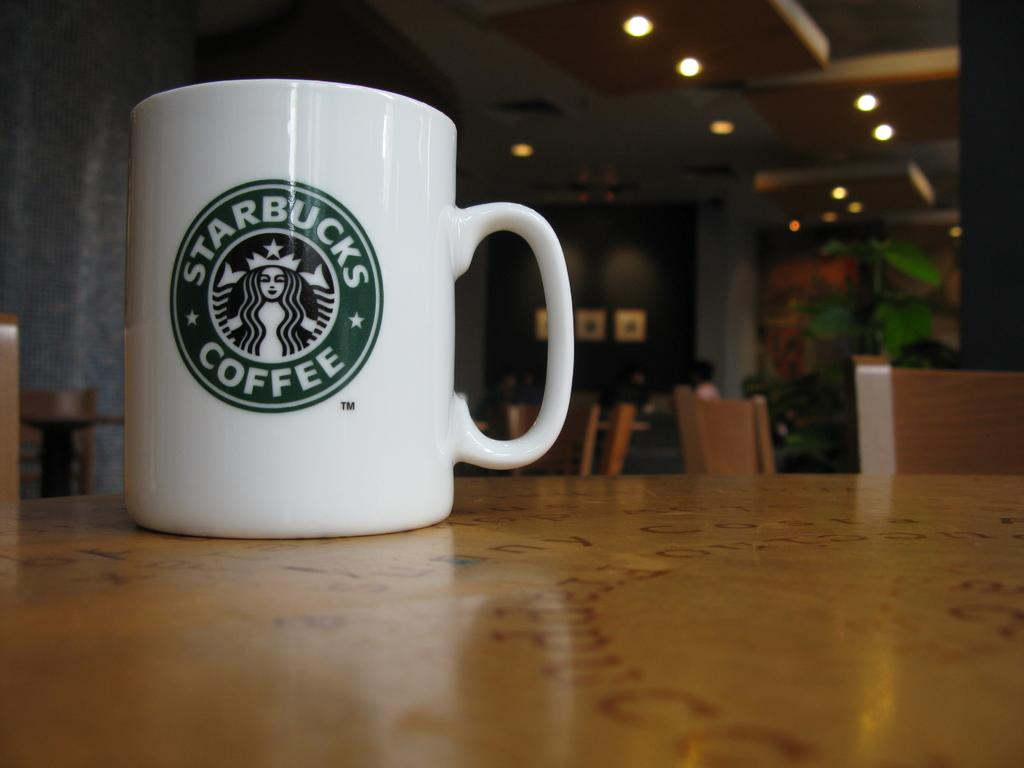<image>
Render a clear and concise summary of the photo. a Starbuck Coffee mug logo on a table top 